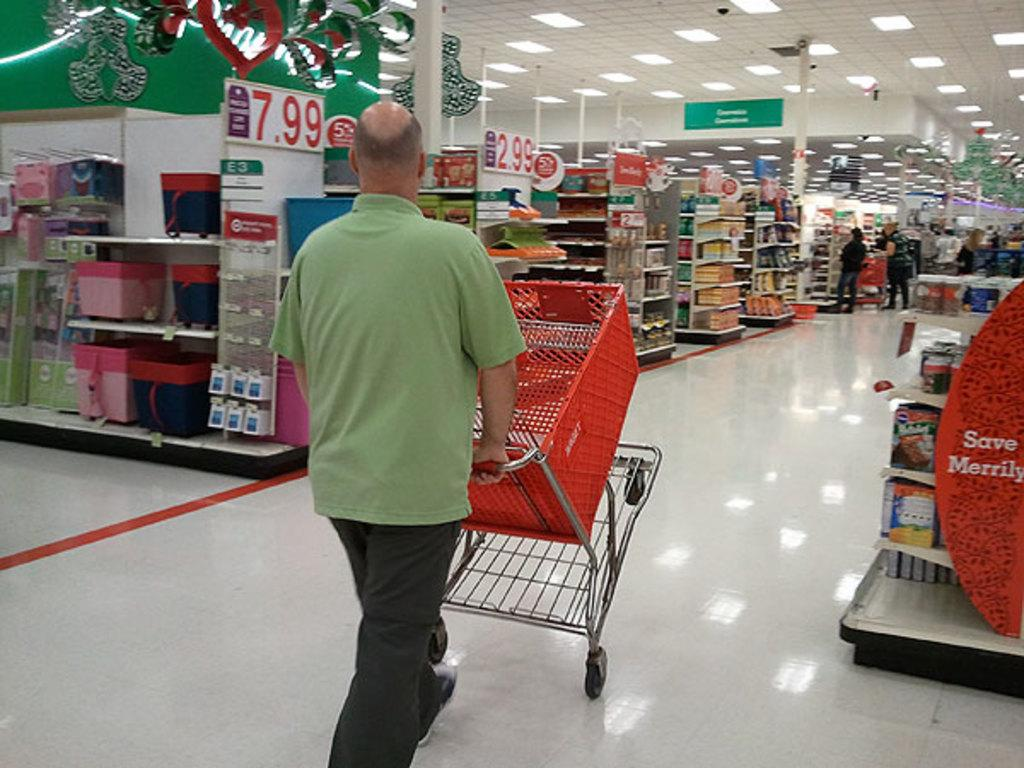<image>
Describe the image concisely. $7.99 reads the price tag hanging on the wall of the closest aisle. 